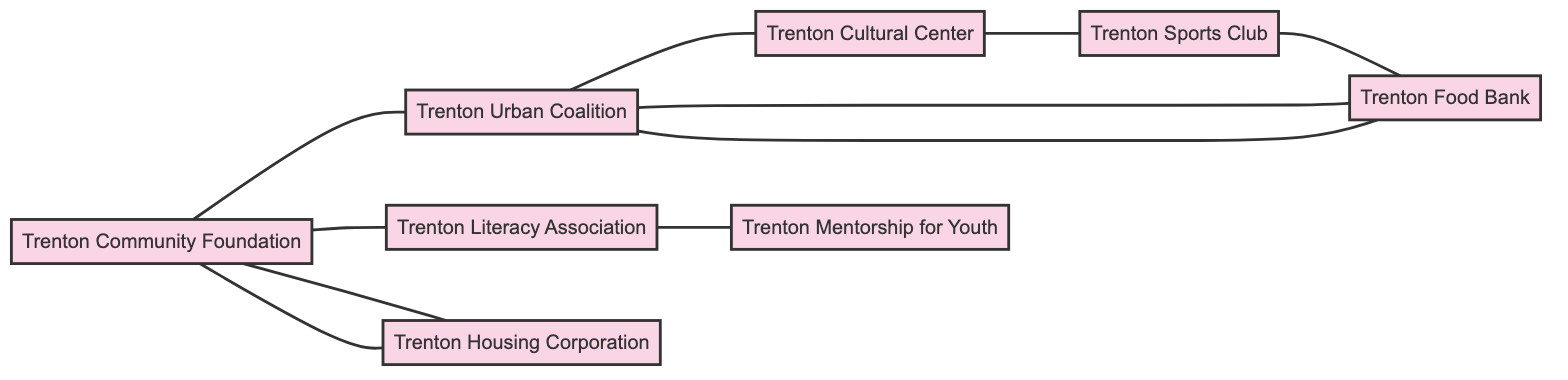What are the total number of organizations in the diagram? The diagram lists eight organizations: Trenton Community Foundation, Trenton Urban Coalition, Trenton Literacy Association, Trenton Housing Corporation, Trenton Cultural Center, Trenton Sports Club, Trenton Mentorship for Youth, and Trenton Food Bank. Counting these gives a total of 8 organizations.
Answer: 8 Which organization collaborates with the Trenton Urban Coalition on community food drives? The diagram shows a link between the Trenton Urban Coalition and the Trenton Food Bank, indicating their collaboration on community food drives.
Answer: Trenton Food Bank What type of collaboration exists between the Trenton Community Foundation and the Trenton Housing Corporation? According to the diagram, the collaboration between the Trenton Community Foundation and the Trenton Housing Corporation is specifically focused on affordable housing projects.
Answer: Affordable Housing Projects How many collaborations involve the Trenton Food Bank? The diagram has three collaborative links involving the Trenton Food Bank: with Trenton Urban Coalition for community food drives, with Trenton Sports Club for sports for food programs, and with Trenton Cultural Center for nutritional workshops. Summing these gives 3 collaborations.
Answer: 3 Which organization is involved in youth literacy programs? The diagram indicates that the Trenton Literacy Association is linked with the Trenton Mentorship for Youth on youth literacy programs. Hence, the Trenton Literacy Association is involved in these programs.
Answer: Trenton Literacy Association Is there a direct collaboration between the Trenton Cultural Center and the Trenton Mentorship for Youth? The diagram does not show any direct link between the Trenton Cultural Center and the Trenton Mentorship for Youth; they do not collaborate directly in any capacity.
Answer: No Which organizations are involved in sports-related activities? The diagram shows two organizations involved in sports-related activities: the Trenton Sports Club, which collaborates with Trenton Cultural Center on cultural and sports events, and the Trenton Food Bank for sports for food programs. Therefore, the involved organizations are Trenton Sports Club and Trenton Food Bank.
Answer: Trenton Sports Club, Trenton Food Bank What type of initiative is collaborated on by the Trenton Urban Coalition and the Trenton Cultural Center? According to the diagram, the collaboration between the Trenton Urban Coalition and the Trenton Cultural Center revolves around urban arts initiatives.
Answer: Urban Arts Initiatives 